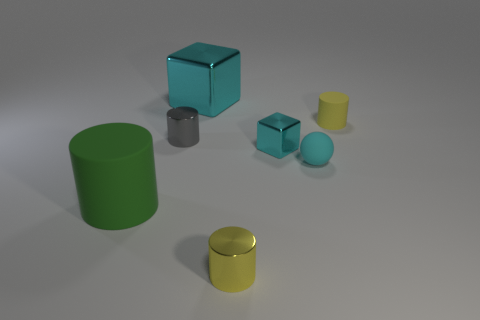Subtract all green matte cylinders. How many cylinders are left? 3 Add 2 green cylinders. How many objects exist? 9 Subtract all balls. How many objects are left? 6 Add 4 cyan matte objects. How many cyan matte objects exist? 5 Subtract all gray cylinders. How many cylinders are left? 3 Subtract 0 yellow balls. How many objects are left? 7 Subtract 1 blocks. How many blocks are left? 1 Subtract all gray spheres. Subtract all gray cylinders. How many spheres are left? 1 Subtract all green cubes. How many gray cylinders are left? 1 Subtract all tiny gray objects. Subtract all metal cylinders. How many objects are left? 4 